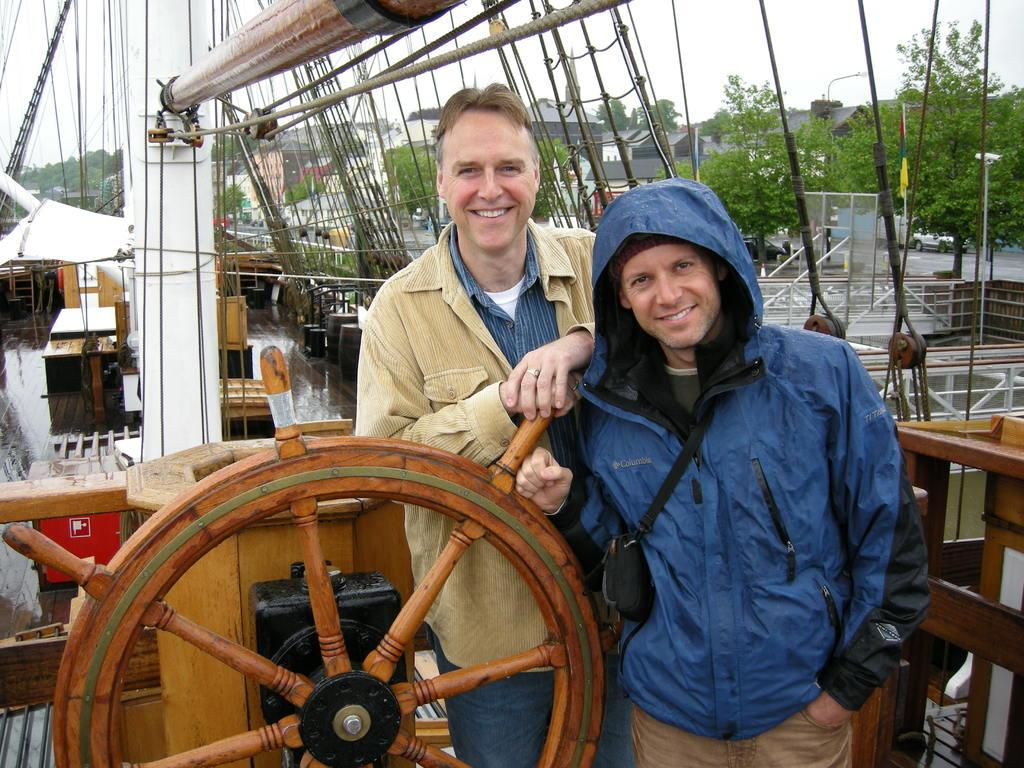How many people are on the ship in the image? There are two persons standing in the image. What can be seen near the ship? There are objects placed near the ship. What type of structures are visible in the image? There are buildings visible in the image. What type of vegetation is visible in the image? There are trees visible in the image. What type of crow is sitting on the island in the image? There is no crow or island present in the image. What emotion can be seen on the faces of the people in the image due to their fear of the island? There is no fear or island present in the image, so it is not possible to determine the emotion on the people's faces based on this information. 